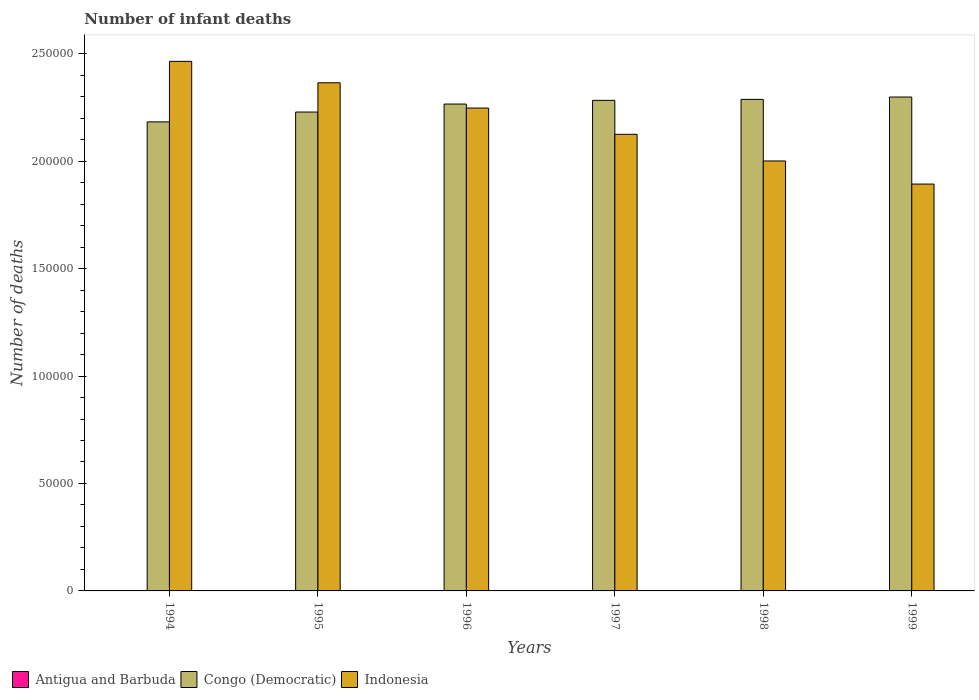Are the number of bars per tick equal to the number of legend labels?
Ensure brevity in your answer.  Yes. What is the label of the 2nd group of bars from the left?
Your response must be concise. 1995. What is the number of infant deaths in Congo (Democratic) in 1994?
Provide a succinct answer. 2.18e+05. Across all years, what is the minimum number of infant deaths in Antigua and Barbuda?
Provide a short and direct response. 22. In which year was the number of infant deaths in Indonesia maximum?
Make the answer very short. 1994. What is the total number of infant deaths in Indonesia in the graph?
Ensure brevity in your answer.  1.31e+06. What is the difference between the number of infant deaths in Indonesia in 1997 and that in 1998?
Your response must be concise. 1.24e+04. What is the difference between the number of infant deaths in Indonesia in 1999 and the number of infant deaths in Congo (Democratic) in 1996?
Provide a succinct answer. -3.72e+04. What is the average number of infant deaths in Antigua and Barbuda per year?
Offer a very short reply. 22.33. In the year 1998, what is the difference between the number of infant deaths in Congo (Democratic) and number of infant deaths in Indonesia?
Give a very brief answer. 2.87e+04. In how many years, is the number of infant deaths in Congo (Democratic) greater than 60000?
Provide a succinct answer. 6. Is the difference between the number of infant deaths in Congo (Democratic) in 1995 and 1999 greater than the difference between the number of infant deaths in Indonesia in 1995 and 1999?
Your answer should be compact. No. What is the difference between the highest and the lowest number of infant deaths in Antigua and Barbuda?
Your answer should be very brief. 1. What does the 2nd bar from the left in 1994 represents?
Provide a short and direct response. Congo (Democratic). What does the 3rd bar from the right in 1997 represents?
Ensure brevity in your answer.  Antigua and Barbuda. Is it the case that in every year, the sum of the number of infant deaths in Indonesia and number of infant deaths in Congo (Democratic) is greater than the number of infant deaths in Antigua and Barbuda?
Provide a short and direct response. Yes. Are all the bars in the graph horizontal?
Your answer should be very brief. No. What is the difference between two consecutive major ticks on the Y-axis?
Offer a terse response. 5.00e+04. Does the graph contain any zero values?
Make the answer very short. No. How many legend labels are there?
Provide a short and direct response. 3. What is the title of the graph?
Keep it short and to the point. Number of infant deaths. What is the label or title of the Y-axis?
Your answer should be very brief. Number of deaths. What is the Number of deaths in Antigua and Barbuda in 1994?
Keep it short and to the point. 22. What is the Number of deaths in Congo (Democratic) in 1994?
Provide a short and direct response. 2.18e+05. What is the Number of deaths in Indonesia in 1994?
Your answer should be compact. 2.46e+05. What is the Number of deaths in Antigua and Barbuda in 1995?
Give a very brief answer. 22. What is the Number of deaths in Congo (Democratic) in 1995?
Make the answer very short. 2.23e+05. What is the Number of deaths of Indonesia in 1995?
Provide a short and direct response. 2.36e+05. What is the Number of deaths in Antigua and Barbuda in 1996?
Your answer should be compact. 22. What is the Number of deaths of Congo (Democratic) in 1996?
Your answer should be compact. 2.27e+05. What is the Number of deaths in Indonesia in 1996?
Keep it short and to the point. 2.25e+05. What is the Number of deaths in Antigua and Barbuda in 1997?
Make the answer very short. 22. What is the Number of deaths in Congo (Democratic) in 1997?
Provide a succinct answer. 2.28e+05. What is the Number of deaths in Indonesia in 1997?
Your response must be concise. 2.13e+05. What is the Number of deaths in Congo (Democratic) in 1998?
Offer a very short reply. 2.29e+05. What is the Number of deaths of Indonesia in 1998?
Ensure brevity in your answer.  2.00e+05. What is the Number of deaths in Congo (Democratic) in 1999?
Keep it short and to the point. 2.30e+05. What is the Number of deaths of Indonesia in 1999?
Offer a very short reply. 1.89e+05. Across all years, what is the maximum Number of deaths of Antigua and Barbuda?
Provide a short and direct response. 23. Across all years, what is the maximum Number of deaths of Congo (Democratic)?
Offer a very short reply. 2.30e+05. Across all years, what is the maximum Number of deaths in Indonesia?
Ensure brevity in your answer.  2.46e+05. Across all years, what is the minimum Number of deaths in Congo (Democratic)?
Keep it short and to the point. 2.18e+05. Across all years, what is the minimum Number of deaths of Indonesia?
Offer a very short reply. 1.89e+05. What is the total Number of deaths of Antigua and Barbuda in the graph?
Offer a terse response. 134. What is the total Number of deaths in Congo (Democratic) in the graph?
Ensure brevity in your answer.  1.35e+06. What is the total Number of deaths in Indonesia in the graph?
Offer a very short reply. 1.31e+06. What is the difference between the Number of deaths of Antigua and Barbuda in 1994 and that in 1995?
Provide a short and direct response. 0. What is the difference between the Number of deaths in Congo (Democratic) in 1994 and that in 1995?
Your answer should be very brief. -4573. What is the difference between the Number of deaths in Indonesia in 1994 and that in 1995?
Your response must be concise. 9973. What is the difference between the Number of deaths in Congo (Democratic) in 1994 and that in 1996?
Give a very brief answer. -8290. What is the difference between the Number of deaths of Indonesia in 1994 and that in 1996?
Offer a terse response. 2.17e+04. What is the difference between the Number of deaths of Antigua and Barbuda in 1994 and that in 1997?
Make the answer very short. 0. What is the difference between the Number of deaths in Congo (Democratic) in 1994 and that in 1997?
Keep it short and to the point. -1.00e+04. What is the difference between the Number of deaths in Indonesia in 1994 and that in 1997?
Ensure brevity in your answer.  3.40e+04. What is the difference between the Number of deaths in Congo (Democratic) in 1994 and that in 1998?
Keep it short and to the point. -1.05e+04. What is the difference between the Number of deaths of Indonesia in 1994 and that in 1998?
Provide a short and direct response. 4.64e+04. What is the difference between the Number of deaths of Congo (Democratic) in 1994 and that in 1999?
Offer a very short reply. -1.16e+04. What is the difference between the Number of deaths of Indonesia in 1994 and that in 1999?
Your answer should be very brief. 5.71e+04. What is the difference between the Number of deaths of Congo (Democratic) in 1995 and that in 1996?
Ensure brevity in your answer.  -3717. What is the difference between the Number of deaths in Indonesia in 1995 and that in 1996?
Ensure brevity in your answer.  1.18e+04. What is the difference between the Number of deaths of Congo (Democratic) in 1995 and that in 1997?
Your answer should be compact. -5439. What is the difference between the Number of deaths of Indonesia in 1995 and that in 1997?
Your answer should be very brief. 2.40e+04. What is the difference between the Number of deaths in Congo (Democratic) in 1995 and that in 1998?
Your response must be concise. -5904. What is the difference between the Number of deaths of Indonesia in 1995 and that in 1998?
Ensure brevity in your answer.  3.64e+04. What is the difference between the Number of deaths in Congo (Democratic) in 1995 and that in 1999?
Your answer should be compact. -6992. What is the difference between the Number of deaths of Indonesia in 1995 and that in 1999?
Provide a short and direct response. 4.71e+04. What is the difference between the Number of deaths of Antigua and Barbuda in 1996 and that in 1997?
Give a very brief answer. 0. What is the difference between the Number of deaths of Congo (Democratic) in 1996 and that in 1997?
Ensure brevity in your answer.  -1722. What is the difference between the Number of deaths of Indonesia in 1996 and that in 1997?
Offer a terse response. 1.22e+04. What is the difference between the Number of deaths in Antigua and Barbuda in 1996 and that in 1998?
Provide a succinct answer. -1. What is the difference between the Number of deaths in Congo (Democratic) in 1996 and that in 1998?
Keep it short and to the point. -2187. What is the difference between the Number of deaths in Indonesia in 1996 and that in 1998?
Provide a short and direct response. 2.46e+04. What is the difference between the Number of deaths in Antigua and Barbuda in 1996 and that in 1999?
Your answer should be very brief. -1. What is the difference between the Number of deaths of Congo (Democratic) in 1996 and that in 1999?
Ensure brevity in your answer.  -3275. What is the difference between the Number of deaths in Indonesia in 1996 and that in 1999?
Your answer should be very brief. 3.54e+04. What is the difference between the Number of deaths of Congo (Democratic) in 1997 and that in 1998?
Your answer should be very brief. -465. What is the difference between the Number of deaths of Indonesia in 1997 and that in 1998?
Your answer should be compact. 1.24e+04. What is the difference between the Number of deaths in Congo (Democratic) in 1997 and that in 1999?
Keep it short and to the point. -1553. What is the difference between the Number of deaths of Indonesia in 1997 and that in 1999?
Your answer should be compact. 2.32e+04. What is the difference between the Number of deaths of Antigua and Barbuda in 1998 and that in 1999?
Your response must be concise. 0. What is the difference between the Number of deaths in Congo (Democratic) in 1998 and that in 1999?
Ensure brevity in your answer.  -1088. What is the difference between the Number of deaths in Indonesia in 1998 and that in 1999?
Your answer should be very brief. 1.08e+04. What is the difference between the Number of deaths in Antigua and Barbuda in 1994 and the Number of deaths in Congo (Democratic) in 1995?
Your response must be concise. -2.23e+05. What is the difference between the Number of deaths in Antigua and Barbuda in 1994 and the Number of deaths in Indonesia in 1995?
Give a very brief answer. -2.36e+05. What is the difference between the Number of deaths in Congo (Democratic) in 1994 and the Number of deaths in Indonesia in 1995?
Offer a terse response. -1.82e+04. What is the difference between the Number of deaths in Antigua and Barbuda in 1994 and the Number of deaths in Congo (Democratic) in 1996?
Provide a short and direct response. -2.27e+05. What is the difference between the Number of deaths of Antigua and Barbuda in 1994 and the Number of deaths of Indonesia in 1996?
Give a very brief answer. -2.25e+05. What is the difference between the Number of deaths in Congo (Democratic) in 1994 and the Number of deaths in Indonesia in 1996?
Your response must be concise. -6432. What is the difference between the Number of deaths in Antigua and Barbuda in 1994 and the Number of deaths in Congo (Democratic) in 1997?
Your response must be concise. -2.28e+05. What is the difference between the Number of deaths of Antigua and Barbuda in 1994 and the Number of deaths of Indonesia in 1997?
Your answer should be compact. -2.12e+05. What is the difference between the Number of deaths in Congo (Democratic) in 1994 and the Number of deaths in Indonesia in 1997?
Make the answer very short. 5794. What is the difference between the Number of deaths in Antigua and Barbuda in 1994 and the Number of deaths in Congo (Democratic) in 1998?
Make the answer very short. -2.29e+05. What is the difference between the Number of deaths of Antigua and Barbuda in 1994 and the Number of deaths of Indonesia in 1998?
Offer a very short reply. -2.00e+05. What is the difference between the Number of deaths in Congo (Democratic) in 1994 and the Number of deaths in Indonesia in 1998?
Offer a terse response. 1.82e+04. What is the difference between the Number of deaths of Antigua and Barbuda in 1994 and the Number of deaths of Congo (Democratic) in 1999?
Your answer should be compact. -2.30e+05. What is the difference between the Number of deaths in Antigua and Barbuda in 1994 and the Number of deaths in Indonesia in 1999?
Give a very brief answer. -1.89e+05. What is the difference between the Number of deaths in Congo (Democratic) in 1994 and the Number of deaths in Indonesia in 1999?
Give a very brief answer. 2.89e+04. What is the difference between the Number of deaths of Antigua and Barbuda in 1995 and the Number of deaths of Congo (Democratic) in 1996?
Make the answer very short. -2.27e+05. What is the difference between the Number of deaths of Antigua and Barbuda in 1995 and the Number of deaths of Indonesia in 1996?
Ensure brevity in your answer.  -2.25e+05. What is the difference between the Number of deaths in Congo (Democratic) in 1995 and the Number of deaths in Indonesia in 1996?
Your answer should be compact. -1859. What is the difference between the Number of deaths of Antigua and Barbuda in 1995 and the Number of deaths of Congo (Democratic) in 1997?
Give a very brief answer. -2.28e+05. What is the difference between the Number of deaths in Antigua and Barbuda in 1995 and the Number of deaths in Indonesia in 1997?
Your answer should be compact. -2.12e+05. What is the difference between the Number of deaths in Congo (Democratic) in 1995 and the Number of deaths in Indonesia in 1997?
Ensure brevity in your answer.  1.04e+04. What is the difference between the Number of deaths in Antigua and Barbuda in 1995 and the Number of deaths in Congo (Democratic) in 1998?
Provide a short and direct response. -2.29e+05. What is the difference between the Number of deaths of Antigua and Barbuda in 1995 and the Number of deaths of Indonesia in 1998?
Give a very brief answer. -2.00e+05. What is the difference between the Number of deaths of Congo (Democratic) in 1995 and the Number of deaths of Indonesia in 1998?
Give a very brief answer. 2.28e+04. What is the difference between the Number of deaths in Antigua and Barbuda in 1995 and the Number of deaths in Congo (Democratic) in 1999?
Keep it short and to the point. -2.30e+05. What is the difference between the Number of deaths of Antigua and Barbuda in 1995 and the Number of deaths of Indonesia in 1999?
Provide a succinct answer. -1.89e+05. What is the difference between the Number of deaths of Congo (Democratic) in 1995 and the Number of deaths of Indonesia in 1999?
Your answer should be very brief. 3.35e+04. What is the difference between the Number of deaths in Antigua and Barbuda in 1996 and the Number of deaths in Congo (Democratic) in 1997?
Provide a short and direct response. -2.28e+05. What is the difference between the Number of deaths of Antigua and Barbuda in 1996 and the Number of deaths of Indonesia in 1997?
Offer a very short reply. -2.12e+05. What is the difference between the Number of deaths of Congo (Democratic) in 1996 and the Number of deaths of Indonesia in 1997?
Offer a terse response. 1.41e+04. What is the difference between the Number of deaths of Antigua and Barbuda in 1996 and the Number of deaths of Congo (Democratic) in 1998?
Your response must be concise. -2.29e+05. What is the difference between the Number of deaths of Antigua and Barbuda in 1996 and the Number of deaths of Indonesia in 1998?
Your response must be concise. -2.00e+05. What is the difference between the Number of deaths of Congo (Democratic) in 1996 and the Number of deaths of Indonesia in 1998?
Ensure brevity in your answer.  2.65e+04. What is the difference between the Number of deaths of Antigua and Barbuda in 1996 and the Number of deaths of Congo (Democratic) in 1999?
Offer a terse response. -2.30e+05. What is the difference between the Number of deaths in Antigua and Barbuda in 1996 and the Number of deaths in Indonesia in 1999?
Make the answer very short. -1.89e+05. What is the difference between the Number of deaths of Congo (Democratic) in 1996 and the Number of deaths of Indonesia in 1999?
Offer a terse response. 3.72e+04. What is the difference between the Number of deaths in Antigua and Barbuda in 1997 and the Number of deaths in Congo (Democratic) in 1998?
Provide a succinct answer. -2.29e+05. What is the difference between the Number of deaths of Antigua and Barbuda in 1997 and the Number of deaths of Indonesia in 1998?
Give a very brief answer. -2.00e+05. What is the difference between the Number of deaths of Congo (Democratic) in 1997 and the Number of deaths of Indonesia in 1998?
Provide a short and direct response. 2.82e+04. What is the difference between the Number of deaths in Antigua and Barbuda in 1997 and the Number of deaths in Congo (Democratic) in 1999?
Your answer should be compact. -2.30e+05. What is the difference between the Number of deaths in Antigua and Barbuda in 1997 and the Number of deaths in Indonesia in 1999?
Your answer should be very brief. -1.89e+05. What is the difference between the Number of deaths in Congo (Democratic) in 1997 and the Number of deaths in Indonesia in 1999?
Provide a succinct answer. 3.90e+04. What is the difference between the Number of deaths of Antigua and Barbuda in 1998 and the Number of deaths of Congo (Democratic) in 1999?
Provide a short and direct response. -2.30e+05. What is the difference between the Number of deaths of Antigua and Barbuda in 1998 and the Number of deaths of Indonesia in 1999?
Your response must be concise. -1.89e+05. What is the difference between the Number of deaths of Congo (Democratic) in 1998 and the Number of deaths of Indonesia in 1999?
Your response must be concise. 3.94e+04. What is the average Number of deaths in Antigua and Barbuda per year?
Your answer should be compact. 22.33. What is the average Number of deaths in Congo (Democratic) per year?
Offer a terse response. 2.26e+05. What is the average Number of deaths of Indonesia per year?
Give a very brief answer. 2.18e+05. In the year 1994, what is the difference between the Number of deaths of Antigua and Barbuda and Number of deaths of Congo (Democratic)?
Ensure brevity in your answer.  -2.18e+05. In the year 1994, what is the difference between the Number of deaths of Antigua and Barbuda and Number of deaths of Indonesia?
Give a very brief answer. -2.46e+05. In the year 1994, what is the difference between the Number of deaths of Congo (Democratic) and Number of deaths of Indonesia?
Your response must be concise. -2.82e+04. In the year 1995, what is the difference between the Number of deaths of Antigua and Barbuda and Number of deaths of Congo (Democratic)?
Make the answer very short. -2.23e+05. In the year 1995, what is the difference between the Number of deaths of Antigua and Barbuda and Number of deaths of Indonesia?
Offer a very short reply. -2.36e+05. In the year 1995, what is the difference between the Number of deaths of Congo (Democratic) and Number of deaths of Indonesia?
Offer a terse response. -1.36e+04. In the year 1996, what is the difference between the Number of deaths in Antigua and Barbuda and Number of deaths in Congo (Democratic)?
Provide a succinct answer. -2.27e+05. In the year 1996, what is the difference between the Number of deaths of Antigua and Barbuda and Number of deaths of Indonesia?
Ensure brevity in your answer.  -2.25e+05. In the year 1996, what is the difference between the Number of deaths of Congo (Democratic) and Number of deaths of Indonesia?
Give a very brief answer. 1858. In the year 1997, what is the difference between the Number of deaths of Antigua and Barbuda and Number of deaths of Congo (Democratic)?
Give a very brief answer. -2.28e+05. In the year 1997, what is the difference between the Number of deaths of Antigua and Barbuda and Number of deaths of Indonesia?
Give a very brief answer. -2.12e+05. In the year 1997, what is the difference between the Number of deaths in Congo (Democratic) and Number of deaths in Indonesia?
Your response must be concise. 1.58e+04. In the year 1998, what is the difference between the Number of deaths in Antigua and Barbuda and Number of deaths in Congo (Democratic)?
Ensure brevity in your answer.  -2.29e+05. In the year 1998, what is the difference between the Number of deaths in Antigua and Barbuda and Number of deaths in Indonesia?
Your answer should be very brief. -2.00e+05. In the year 1998, what is the difference between the Number of deaths of Congo (Democratic) and Number of deaths of Indonesia?
Your answer should be very brief. 2.87e+04. In the year 1999, what is the difference between the Number of deaths of Antigua and Barbuda and Number of deaths of Congo (Democratic)?
Your answer should be very brief. -2.30e+05. In the year 1999, what is the difference between the Number of deaths of Antigua and Barbuda and Number of deaths of Indonesia?
Your response must be concise. -1.89e+05. In the year 1999, what is the difference between the Number of deaths in Congo (Democratic) and Number of deaths in Indonesia?
Your response must be concise. 4.05e+04. What is the ratio of the Number of deaths of Antigua and Barbuda in 1994 to that in 1995?
Keep it short and to the point. 1. What is the ratio of the Number of deaths in Congo (Democratic) in 1994 to that in 1995?
Provide a succinct answer. 0.98. What is the ratio of the Number of deaths of Indonesia in 1994 to that in 1995?
Ensure brevity in your answer.  1.04. What is the ratio of the Number of deaths of Antigua and Barbuda in 1994 to that in 1996?
Keep it short and to the point. 1. What is the ratio of the Number of deaths of Congo (Democratic) in 1994 to that in 1996?
Provide a succinct answer. 0.96. What is the ratio of the Number of deaths in Indonesia in 1994 to that in 1996?
Offer a very short reply. 1.1. What is the ratio of the Number of deaths in Antigua and Barbuda in 1994 to that in 1997?
Make the answer very short. 1. What is the ratio of the Number of deaths in Congo (Democratic) in 1994 to that in 1997?
Provide a short and direct response. 0.96. What is the ratio of the Number of deaths in Indonesia in 1994 to that in 1997?
Keep it short and to the point. 1.16. What is the ratio of the Number of deaths of Antigua and Barbuda in 1994 to that in 1998?
Make the answer very short. 0.96. What is the ratio of the Number of deaths in Congo (Democratic) in 1994 to that in 1998?
Provide a short and direct response. 0.95. What is the ratio of the Number of deaths of Indonesia in 1994 to that in 1998?
Make the answer very short. 1.23. What is the ratio of the Number of deaths of Antigua and Barbuda in 1994 to that in 1999?
Your response must be concise. 0.96. What is the ratio of the Number of deaths of Congo (Democratic) in 1994 to that in 1999?
Your response must be concise. 0.95. What is the ratio of the Number of deaths of Indonesia in 1994 to that in 1999?
Ensure brevity in your answer.  1.3. What is the ratio of the Number of deaths of Antigua and Barbuda in 1995 to that in 1996?
Your answer should be compact. 1. What is the ratio of the Number of deaths in Congo (Democratic) in 1995 to that in 1996?
Keep it short and to the point. 0.98. What is the ratio of the Number of deaths in Indonesia in 1995 to that in 1996?
Your response must be concise. 1.05. What is the ratio of the Number of deaths of Antigua and Barbuda in 1995 to that in 1997?
Your answer should be very brief. 1. What is the ratio of the Number of deaths of Congo (Democratic) in 1995 to that in 1997?
Ensure brevity in your answer.  0.98. What is the ratio of the Number of deaths of Indonesia in 1995 to that in 1997?
Offer a terse response. 1.11. What is the ratio of the Number of deaths in Antigua and Barbuda in 1995 to that in 1998?
Your response must be concise. 0.96. What is the ratio of the Number of deaths of Congo (Democratic) in 1995 to that in 1998?
Give a very brief answer. 0.97. What is the ratio of the Number of deaths of Indonesia in 1995 to that in 1998?
Give a very brief answer. 1.18. What is the ratio of the Number of deaths in Antigua and Barbuda in 1995 to that in 1999?
Provide a succinct answer. 0.96. What is the ratio of the Number of deaths of Congo (Democratic) in 1995 to that in 1999?
Your response must be concise. 0.97. What is the ratio of the Number of deaths in Indonesia in 1995 to that in 1999?
Your answer should be very brief. 1.25. What is the ratio of the Number of deaths of Indonesia in 1996 to that in 1997?
Your answer should be very brief. 1.06. What is the ratio of the Number of deaths in Antigua and Barbuda in 1996 to that in 1998?
Offer a terse response. 0.96. What is the ratio of the Number of deaths of Congo (Democratic) in 1996 to that in 1998?
Offer a very short reply. 0.99. What is the ratio of the Number of deaths of Indonesia in 1996 to that in 1998?
Give a very brief answer. 1.12. What is the ratio of the Number of deaths of Antigua and Barbuda in 1996 to that in 1999?
Make the answer very short. 0.96. What is the ratio of the Number of deaths of Congo (Democratic) in 1996 to that in 1999?
Offer a terse response. 0.99. What is the ratio of the Number of deaths of Indonesia in 1996 to that in 1999?
Ensure brevity in your answer.  1.19. What is the ratio of the Number of deaths of Antigua and Barbuda in 1997 to that in 1998?
Your answer should be very brief. 0.96. What is the ratio of the Number of deaths in Congo (Democratic) in 1997 to that in 1998?
Give a very brief answer. 1. What is the ratio of the Number of deaths in Indonesia in 1997 to that in 1998?
Provide a short and direct response. 1.06. What is the ratio of the Number of deaths in Antigua and Barbuda in 1997 to that in 1999?
Provide a succinct answer. 0.96. What is the ratio of the Number of deaths in Congo (Democratic) in 1997 to that in 1999?
Your answer should be compact. 0.99. What is the ratio of the Number of deaths in Indonesia in 1997 to that in 1999?
Give a very brief answer. 1.12. What is the ratio of the Number of deaths of Antigua and Barbuda in 1998 to that in 1999?
Your response must be concise. 1. What is the ratio of the Number of deaths of Congo (Democratic) in 1998 to that in 1999?
Make the answer very short. 1. What is the ratio of the Number of deaths of Indonesia in 1998 to that in 1999?
Offer a very short reply. 1.06. What is the difference between the highest and the second highest Number of deaths in Antigua and Barbuda?
Offer a terse response. 0. What is the difference between the highest and the second highest Number of deaths of Congo (Democratic)?
Your response must be concise. 1088. What is the difference between the highest and the second highest Number of deaths of Indonesia?
Your answer should be compact. 9973. What is the difference between the highest and the lowest Number of deaths of Congo (Democratic)?
Your response must be concise. 1.16e+04. What is the difference between the highest and the lowest Number of deaths of Indonesia?
Provide a succinct answer. 5.71e+04. 